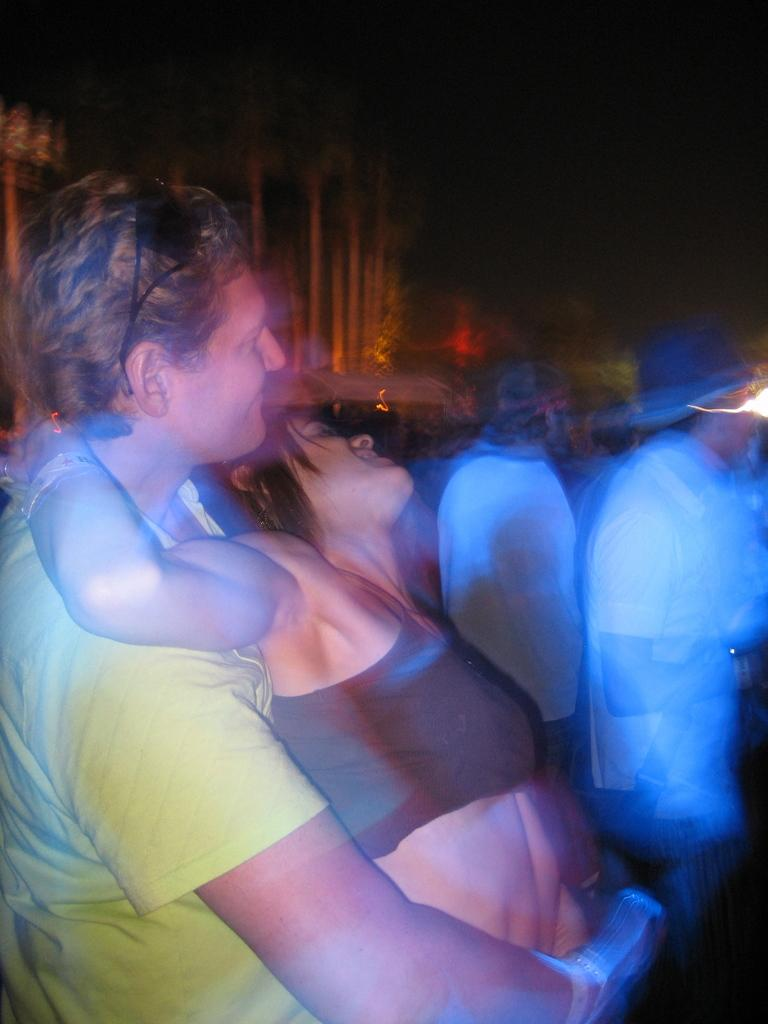Who are the two people in the image? There is a man and a lady in the image. What are the man and lady doing in the image? The man and lady are standing. What can be seen in the background of the image? There are lights and people visible in the background of the image. What type of sound can be heard coming from the swing in the image? There is no swing present in the image, so it is not possible to determine what sound might be heard. 